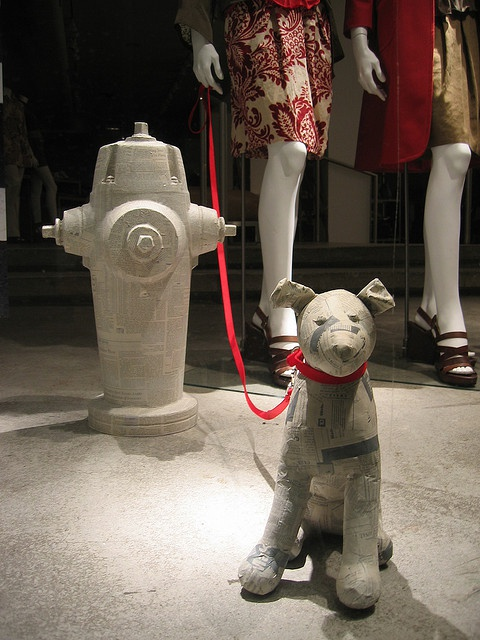Describe the objects in this image and their specific colors. I can see fire hydrant in black, gray, and darkgray tones and dog in black, gray, and darkgray tones in this image. 